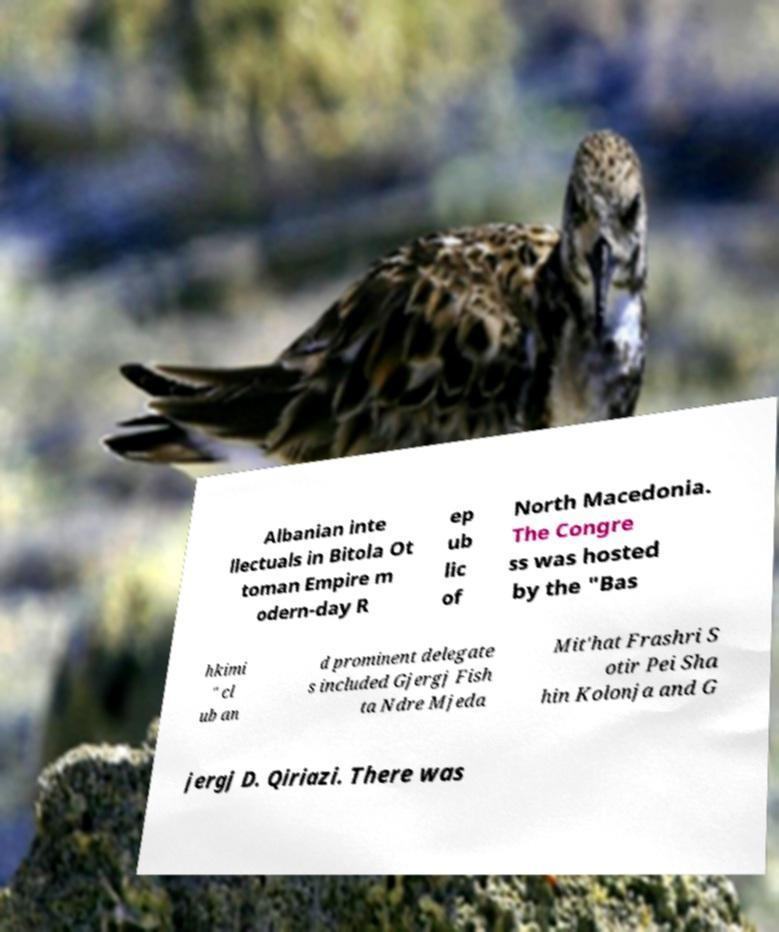Could you assist in decoding the text presented in this image and type it out clearly? Albanian inte llectuals in Bitola Ot toman Empire m odern-day R ep ub lic of North Macedonia. The Congre ss was hosted by the "Bas hkimi " cl ub an d prominent delegate s included Gjergj Fish ta Ndre Mjeda Mit'hat Frashri S otir Pei Sha hin Kolonja and G jergj D. Qiriazi. There was 